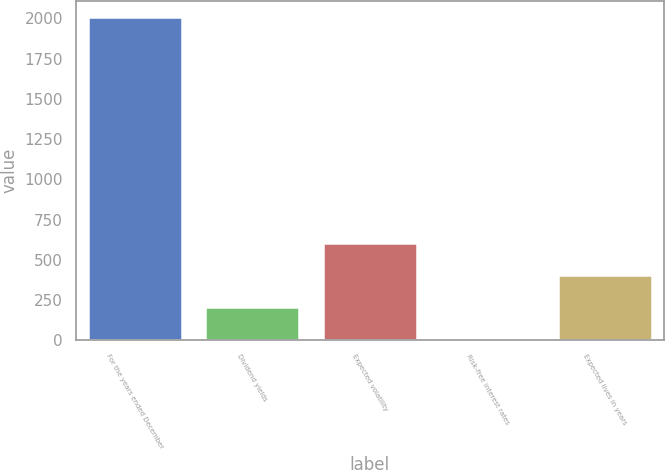Convert chart. <chart><loc_0><loc_0><loc_500><loc_500><bar_chart><fcel>For the years ended December<fcel>Dividend yields<fcel>Expected volatility<fcel>Risk-free interest rates<fcel>Expected lives in years<nl><fcel>2010<fcel>203.79<fcel>605.17<fcel>3.1<fcel>404.48<nl></chart> 